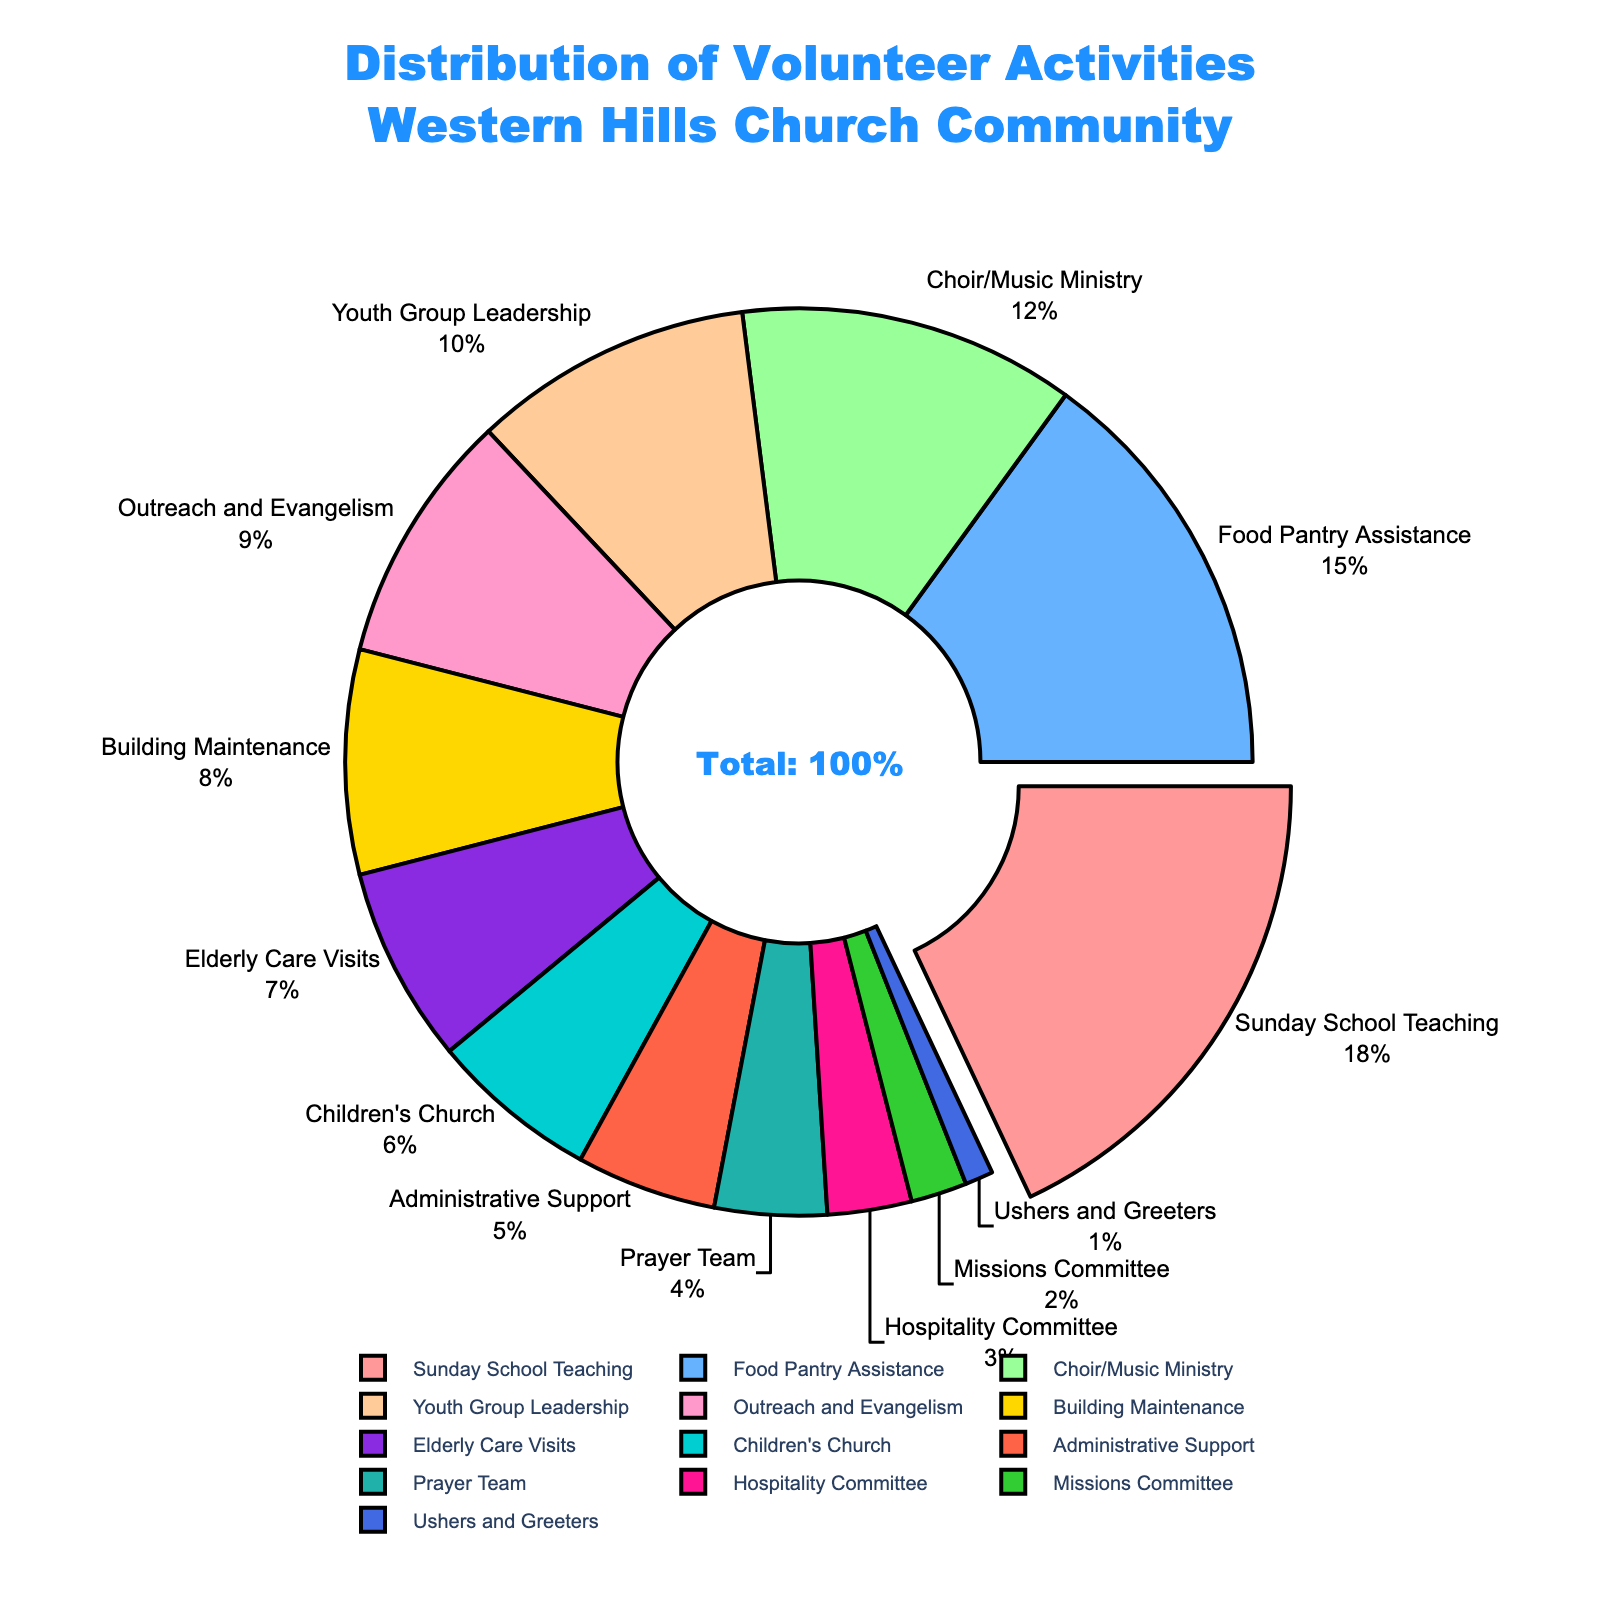Who spends more time on volunteer activities, the Food Pantry Assistance group or the Youth Group Leadership group? To find the answer, we compare the percentages for Food Pantry Assistance (15%) and Youth Group Leadership (10%). Since 15% is greater than 10%, the Food Pantry Assistance group spends more time on volunteer activities.
Answer: Food Pantry Assistance Which activity has the smallest percentage of participation? We look for the activity with the smallest percentage in the pie chart, which is Ushers and Greeters at 1%.
Answer: Ushers and Greeters How much larger is the percentage for Sunday School Teaching compared to Elderly Care Visits? First, identify the percentages: Sunday School Teaching (18%) and Elderly Care Visits (7%). Subtract the smaller from the larger: 18% - 7% = 11%.
Answer: 11% What is the combined percentage of the Choir/Music Ministry and Outreach and Evangelism activities? Add the percentages for Choir/Music Ministry (12%) and Outreach and Evangelism (9%): 12% + 9% = 21%.
Answer: 21% Which activity has a larger percentage, Building Maintenance or Children's Church? Compare the percentages for Building Maintenance (8%) and Children's Church (6%). Since 8% is greater than 6%, Building Maintenance has a larger percentage.
Answer: Building Maintenance Which color represents the Prayer Team on the pie chart? Refer to the visual pie chart to match the color with Prayer Team, which is represented by a purple section.
Answer: Purple If you add the percentages of the Elderly Care Visits, Administrative Support, and Hospitality Committee, what is the total? Add the percentages: Elderly Care Visits (7%) + Administrative Support (5%) + Hospitality Committee (3%) = 7% + 5% + 3% = 15%.
Answer: 15% What is the median percentage of all the activities listed? First, rank all the percentages in ascending order: 1%, 2%, 3%, 4%, 5%, 6%, 7%, 8%, 9%, 10%, 12%, 15%, 18%. With 13 data points, the median is the 7th value: 7%.
Answer: 7% Which activity is highlighted more prominently in the pie chart, and why? The pie chart pulls out the segment with the highest percentage, which is Sunday School Teaching at 18%, making it more prominent.
Answer: Sunday School Teaching What percentage of volunteer activities is not accounted for by the top three activities? Identify the top three activities and their percentages: Sunday School Teaching (18%), Food Pantry Assistance (15%), Choir/Music Ministry (12%). Add these: 18% + 15% + 12% = 45%. Subtract from 100% to find the remaining: 100% - 45% = 55%.
Answer: 55% 